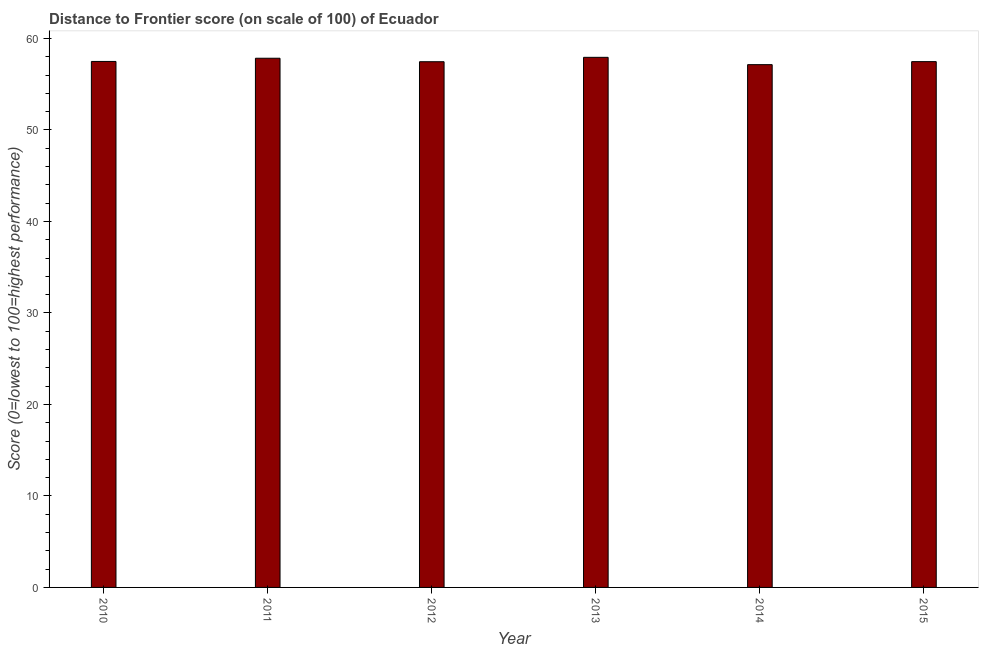Does the graph contain any zero values?
Your answer should be compact. No. Does the graph contain grids?
Make the answer very short. No. What is the title of the graph?
Give a very brief answer. Distance to Frontier score (on scale of 100) of Ecuador. What is the label or title of the Y-axis?
Offer a very short reply. Score (0=lowest to 100=highest performance). What is the distance to frontier score in 2010?
Provide a succinct answer. 57.49. Across all years, what is the maximum distance to frontier score?
Provide a succinct answer. 57.94. Across all years, what is the minimum distance to frontier score?
Make the answer very short. 57.14. In which year was the distance to frontier score minimum?
Provide a succinct answer. 2014. What is the sum of the distance to frontier score?
Offer a very short reply. 345.34. What is the difference between the distance to frontier score in 2010 and 2011?
Provide a short and direct response. -0.35. What is the average distance to frontier score per year?
Your response must be concise. 57.56. What is the median distance to frontier score?
Your answer should be very brief. 57.48. In how many years, is the distance to frontier score greater than 46 ?
Provide a succinct answer. 6. Do a majority of the years between 2011 and 2012 (inclusive) have distance to frontier score greater than 30 ?
Keep it short and to the point. Yes. Are all the bars in the graph horizontal?
Provide a short and direct response. No. What is the Score (0=lowest to 100=highest performance) of 2010?
Offer a terse response. 57.49. What is the Score (0=lowest to 100=highest performance) of 2011?
Provide a succinct answer. 57.84. What is the Score (0=lowest to 100=highest performance) of 2012?
Your response must be concise. 57.46. What is the Score (0=lowest to 100=highest performance) in 2013?
Keep it short and to the point. 57.94. What is the Score (0=lowest to 100=highest performance) of 2014?
Ensure brevity in your answer.  57.14. What is the Score (0=lowest to 100=highest performance) in 2015?
Ensure brevity in your answer.  57.47. What is the difference between the Score (0=lowest to 100=highest performance) in 2010 and 2011?
Your answer should be very brief. -0.35. What is the difference between the Score (0=lowest to 100=highest performance) in 2010 and 2013?
Your answer should be very brief. -0.45. What is the difference between the Score (0=lowest to 100=highest performance) in 2011 and 2012?
Your response must be concise. 0.38. What is the difference between the Score (0=lowest to 100=highest performance) in 2011 and 2014?
Offer a very short reply. 0.7. What is the difference between the Score (0=lowest to 100=highest performance) in 2011 and 2015?
Make the answer very short. 0.37. What is the difference between the Score (0=lowest to 100=highest performance) in 2012 and 2013?
Offer a terse response. -0.48. What is the difference between the Score (0=lowest to 100=highest performance) in 2012 and 2014?
Give a very brief answer. 0.32. What is the difference between the Score (0=lowest to 100=highest performance) in 2012 and 2015?
Ensure brevity in your answer.  -0.01. What is the difference between the Score (0=lowest to 100=highest performance) in 2013 and 2015?
Ensure brevity in your answer.  0.47. What is the difference between the Score (0=lowest to 100=highest performance) in 2014 and 2015?
Your answer should be very brief. -0.33. What is the ratio of the Score (0=lowest to 100=highest performance) in 2010 to that in 2013?
Your answer should be very brief. 0.99. What is the ratio of the Score (0=lowest to 100=highest performance) in 2011 to that in 2012?
Give a very brief answer. 1.01. What is the ratio of the Score (0=lowest to 100=highest performance) in 2011 to that in 2013?
Make the answer very short. 1. What is the ratio of the Score (0=lowest to 100=highest performance) in 2013 to that in 2014?
Your answer should be very brief. 1.01. What is the ratio of the Score (0=lowest to 100=highest performance) in 2013 to that in 2015?
Provide a succinct answer. 1.01. What is the ratio of the Score (0=lowest to 100=highest performance) in 2014 to that in 2015?
Provide a succinct answer. 0.99. 